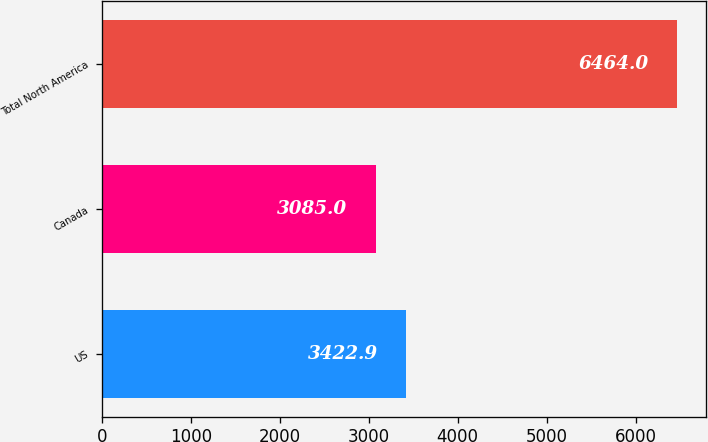Convert chart to OTSL. <chart><loc_0><loc_0><loc_500><loc_500><bar_chart><fcel>US<fcel>Canada<fcel>Total North America<nl><fcel>3422.9<fcel>3085<fcel>6464<nl></chart> 